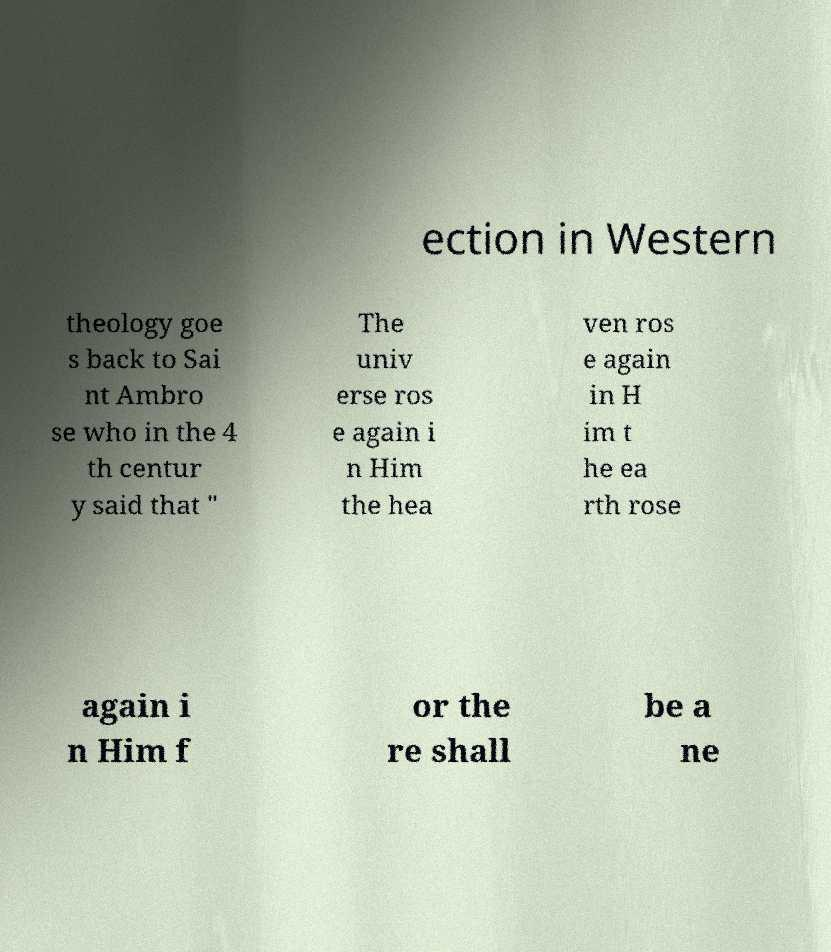Can you read and provide the text displayed in the image?This photo seems to have some interesting text. Can you extract and type it out for me? ection in Western theology goe s back to Sai nt Ambro se who in the 4 th centur y said that " The univ erse ros e again i n Him the hea ven ros e again in H im t he ea rth rose again i n Him f or the re shall be a ne 